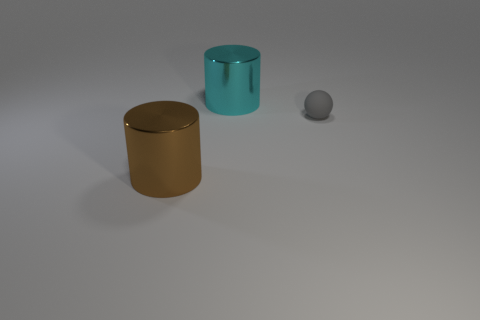Is there anything else that has the same size as the gray matte thing?
Provide a short and direct response. No. Is the number of big metallic things to the left of the brown cylinder greater than the number of cyan cylinders?
Give a very brief answer. No. There is a big brown thing; what number of tiny rubber spheres are to the left of it?
Offer a terse response. 0. Is there a purple metal ball that has the same size as the brown metallic object?
Offer a terse response. No. What color is the other large thing that is the same shape as the large cyan object?
Your response must be concise. Brown. There is a metal cylinder on the left side of the cyan cylinder; is it the same size as the object behind the gray ball?
Provide a short and direct response. Yes. Are there any gray rubber objects that have the same shape as the big brown thing?
Provide a succinct answer. No. Are there an equal number of shiny cylinders in front of the brown cylinder and green shiny cylinders?
Your answer should be compact. Yes. There is a rubber thing; is its size the same as the metallic cylinder behind the gray matte sphere?
Make the answer very short. No. What number of large cyan cylinders have the same material as the gray sphere?
Offer a very short reply. 0. 